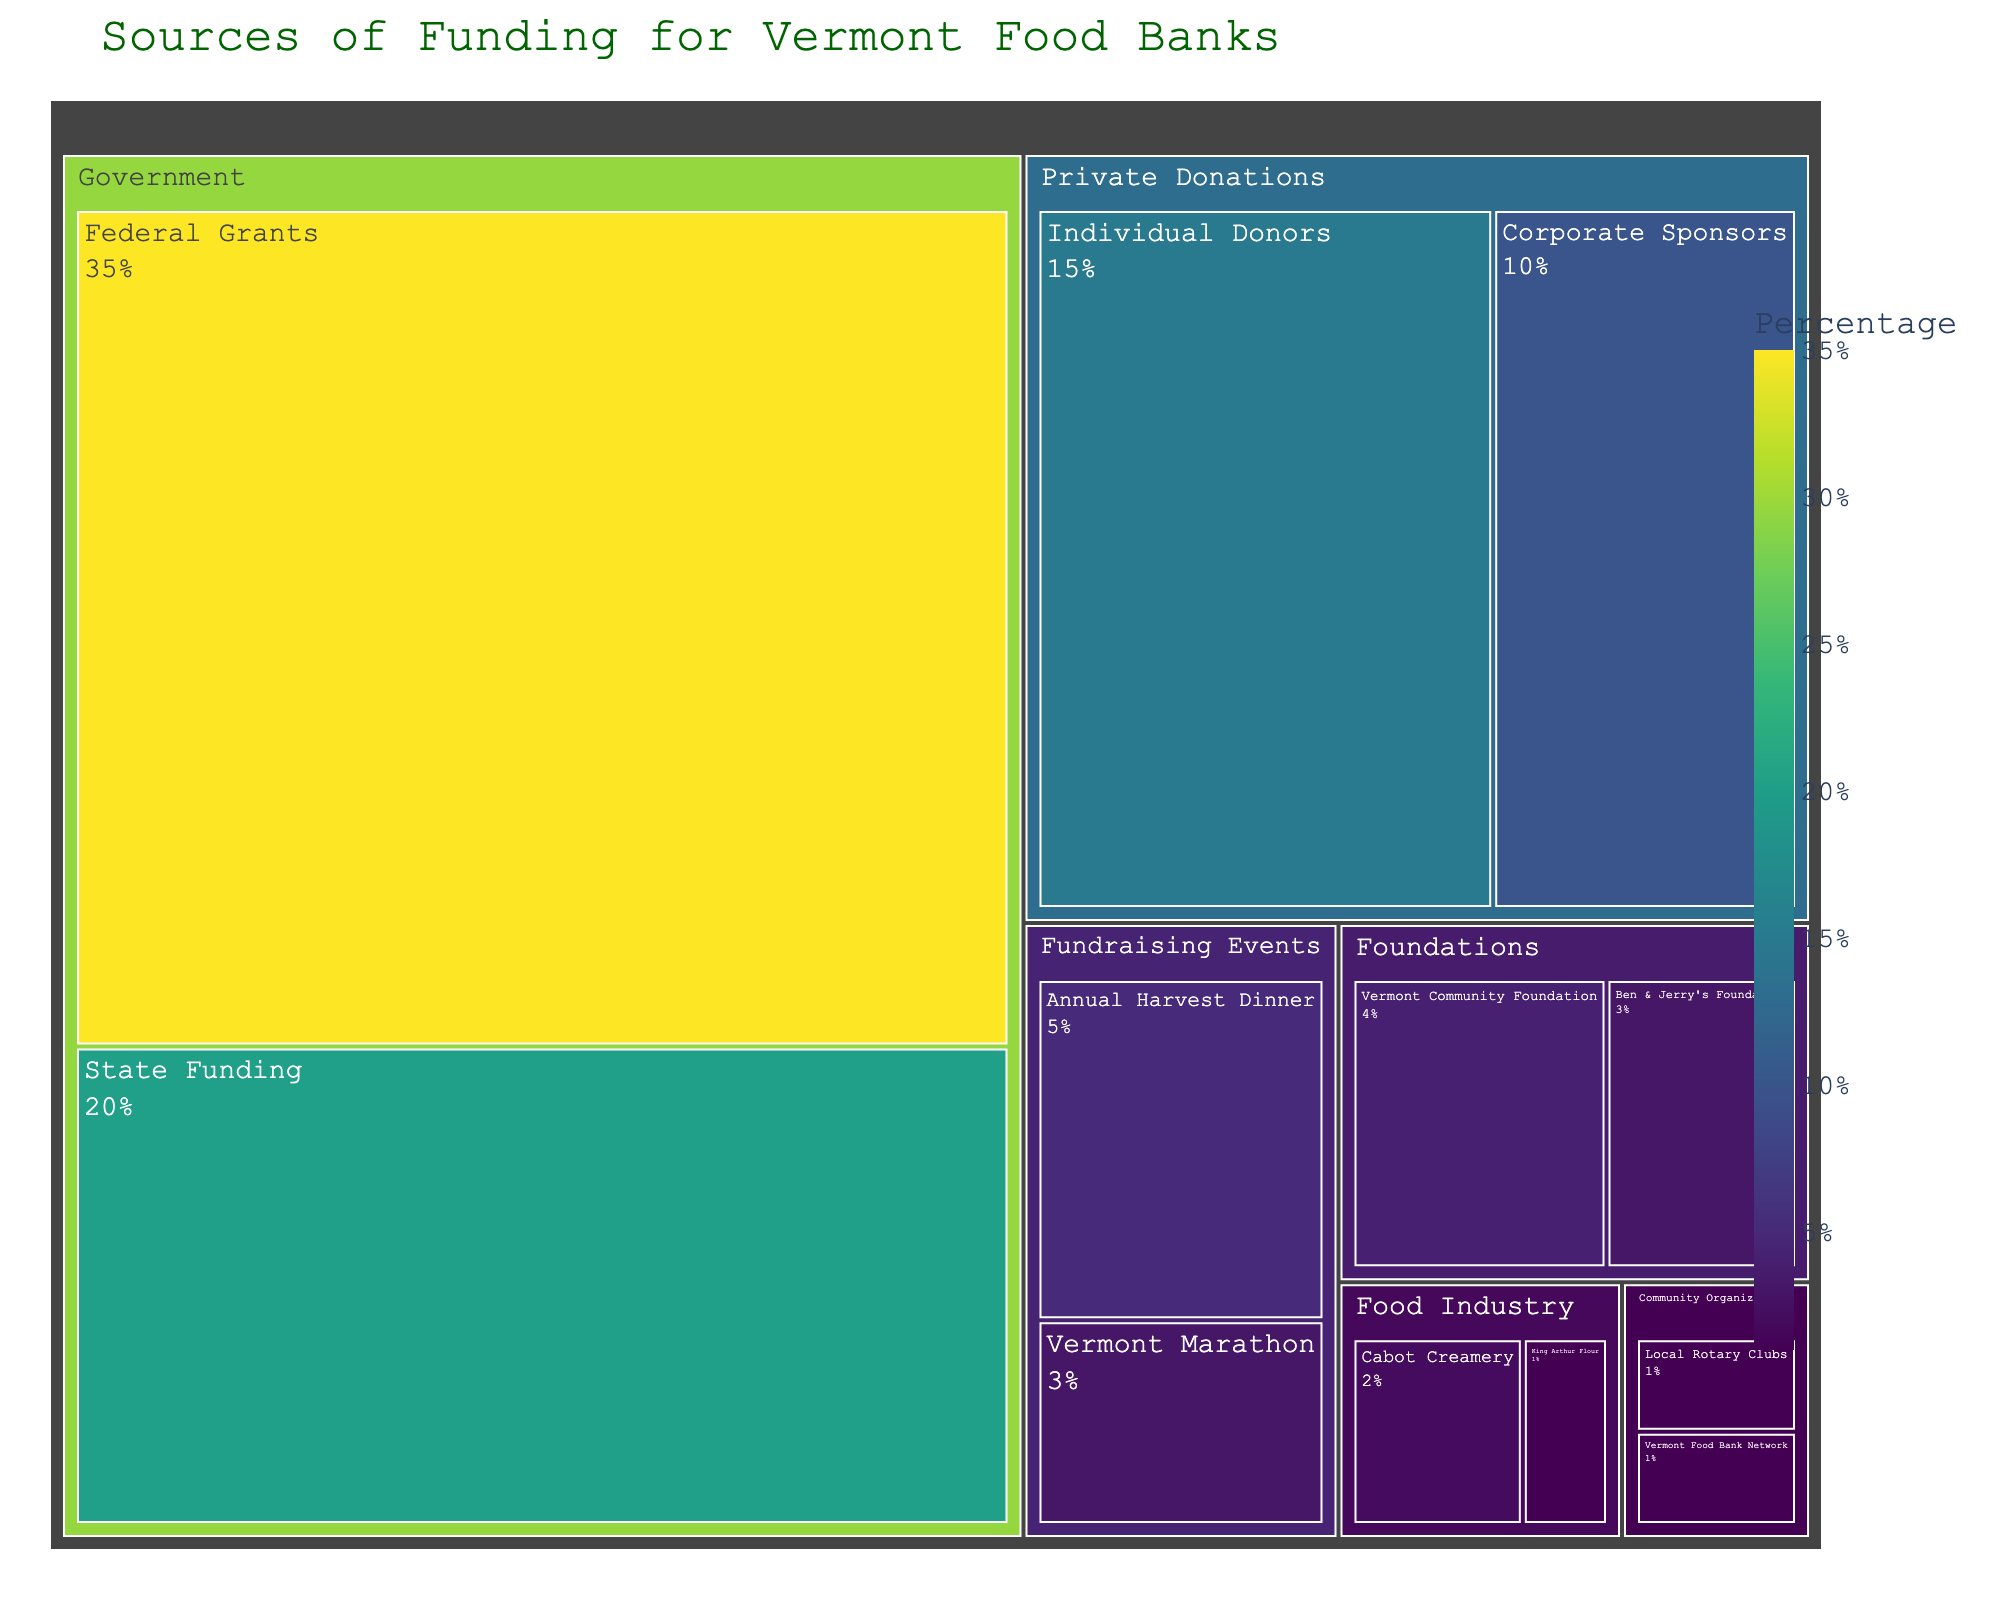What is the title of the treemap? The title is typically located at the top of the figure and is meant to describe what the figure is about. In this case, it should be something related to funding sources for Vermont food banks.
Answer: Sources of Funding for Vermont Food Banks What percentage of the funding comes from Federal Grants? The Federal Grants can be found under the Government category in the treemap. Sum their percentage values, if there's only one value directly provided, use it.
Answer: 35% Which category has the smallest contribution percentage and what is it? Look for the smallest rectangle in the treemap and read the category and its corresponding percentage value.
Answer: Community Organizations, 1% How does the percentage contribution from Corporate Sponsors compare to Individual Donors? Locate both subcategories under Private Donations and compare their percentages. Subtract Corporate Sponsors' value from Individual Donors' value.
Answer: Individual Donors is 15% and Corporate Sponsors is 10%, so Individual Donors contribute 5% more What is the combined percentage of funding from Government sources? Sum the contributions from each Government subcategory; Federal Grants and State Funding.
Answer: 35% + 20% = 55% Which fundraising event contributes more to the funding, and by how much? Identify the two fundraising events and their contribution values from the treemap. Subtract the smaller value from the larger value.
Answer: Annual Harvest Dinner contributes more, by 2% (5% - 3%) How much total percentage do the foundations contribute? Sum the percentage values from the subcategories under Foundations: Vermont Community Foundation and Ben & Jerry's Foundation.
Answer: 4% + 3% = 7% How does the support from the Food Industry compare overall to donations from Individual Donors? Find the combined contributions from Food Industry subcategories (Cabot Creamery and King Arthur Flour) and compare to Individual Donors.
Answer: Food Industry is 2% + 1% = 3%, which is 12% less than Individual Donors at 15% In terms of percentage, what is the difference between the highest and lowest contribution categories? Identify the highest (Federal Grants) and lowest (Community Organizations) contribution categories from the treemap and calculate the difference in their percentages.
Answer: 35% (Federal Grants) - 1% (Community Organizations) = 34% What color scale is used in this treemap to represent percentages? Observe the color gradient in the treemap, which typically indicates the scale used for representing different values.
Answer: Viridis 